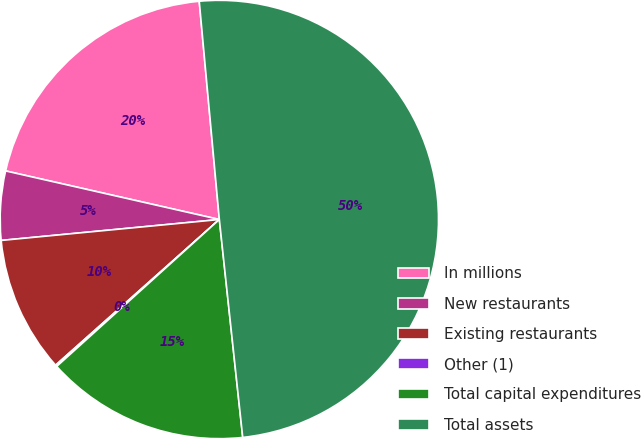Convert chart. <chart><loc_0><loc_0><loc_500><loc_500><pie_chart><fcel>In millions<fcel>New restaurants<fcel>Existing restaurants<fcel>Other (1)<fcel>Total capital expenditures<fcel>Total assets<nl><fcel>19.98%<fcel>5.08%<fcel>10.05%<fcel>0.12%<fcel>15.01%<fcel>49.76%<nl></chart> 